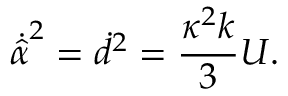<formula> <loc_0><loc_0><loc_500><loc_500>\dot { \hat { \alpha } } ^ { 2 } = \dot { d } ^ { 2 } = \frac { \kappa ^ { 2 } k } { 3 } U .</formula> 